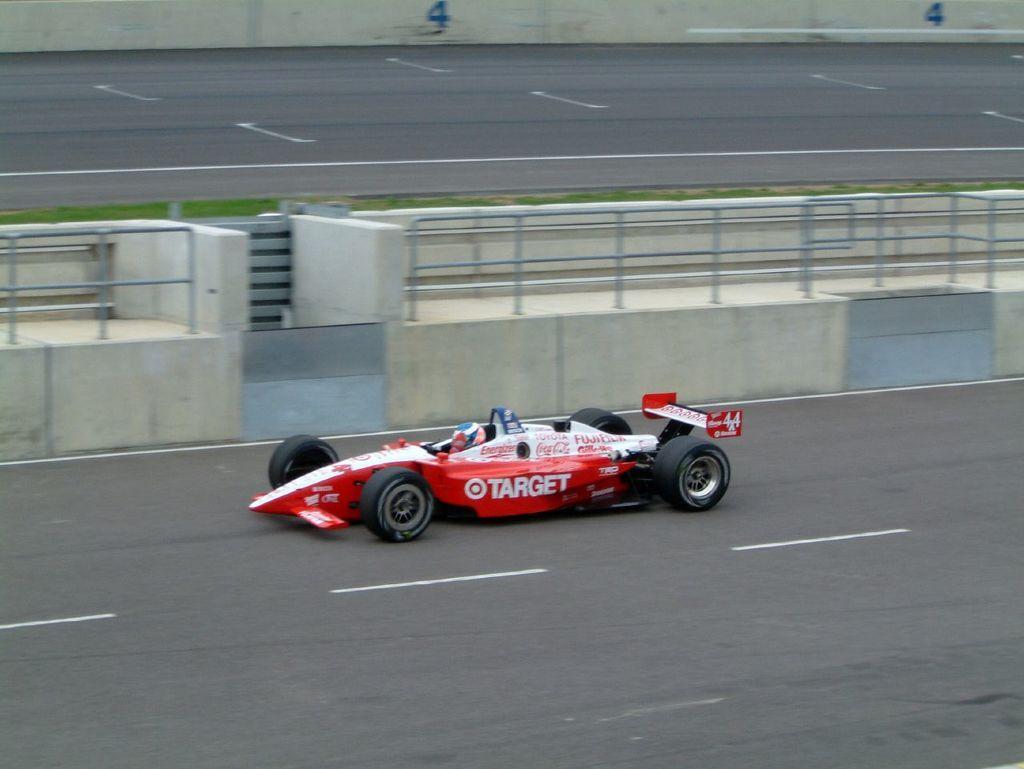Can you describe this image briefly? In the picture I can see a person riding a formula one car on the road. I can see the stainless steel fencing and green grass on the side of the road. 